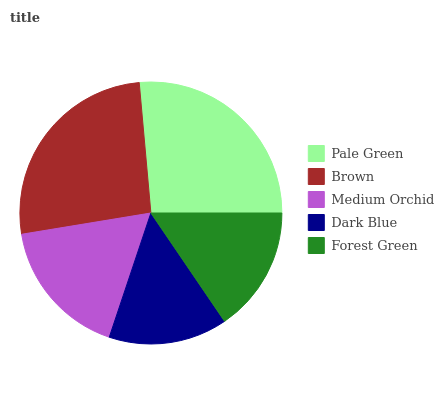Is Dark Blue the minimum?
Answer yes or no. Yes. Is Pale Green the maximum?
Answer yes or no. Yes. Is Brown the minimum?
Answer yes or no. No. Is Brown the maximum?
Answer yes or no. No. Is Pale Green greater than Brown?
Answer yes or no. Yes. Is Brown less than Pale Green?
Answer yes or no. Yes. Is Brown greater than Pale Green?
Answer yes or no. No. Is Pale Green less than Brown?
Answer yes or no. No. Is Medium Orchid the high median?
Answer yes or no. Yes. Is Medium Orchid the low median?
Answer yes or no. Yes. Is Forest Green the high median?
Answer yes or no. No. Is Dark Blue the low median?
Answer yes or no. No. 